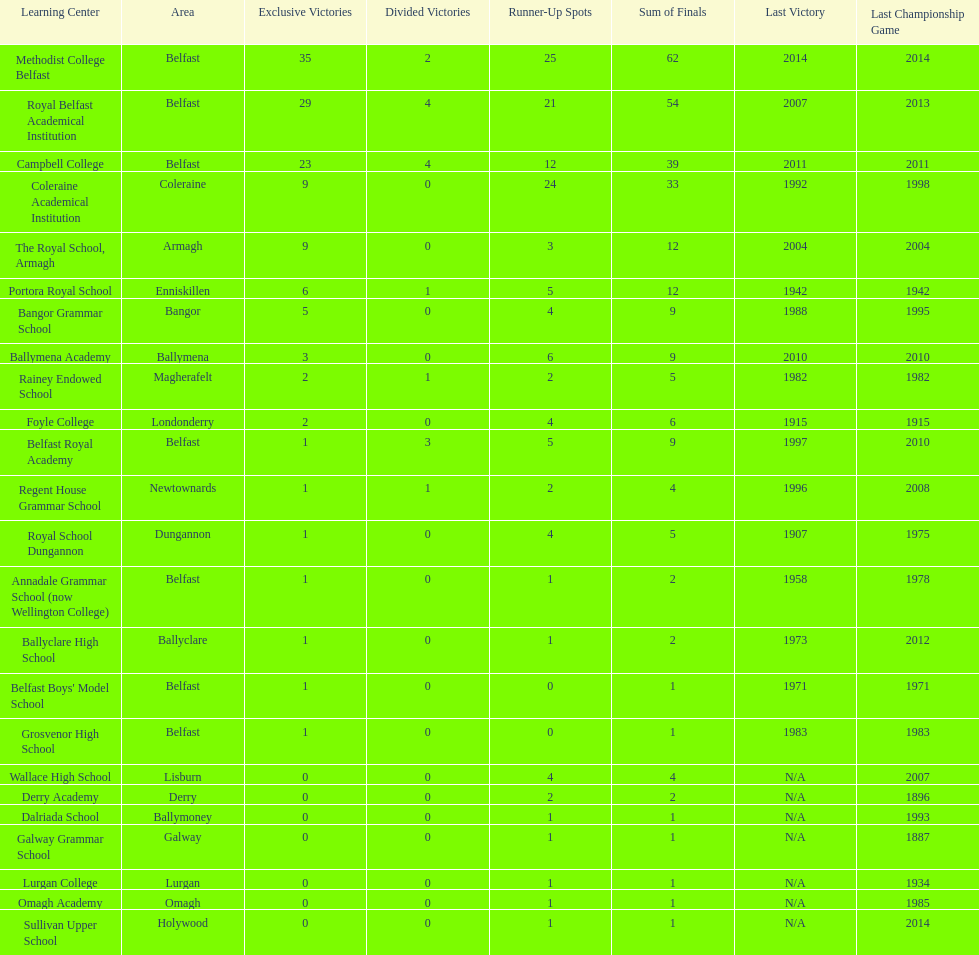What number of total finals does foyle college have? 6. 